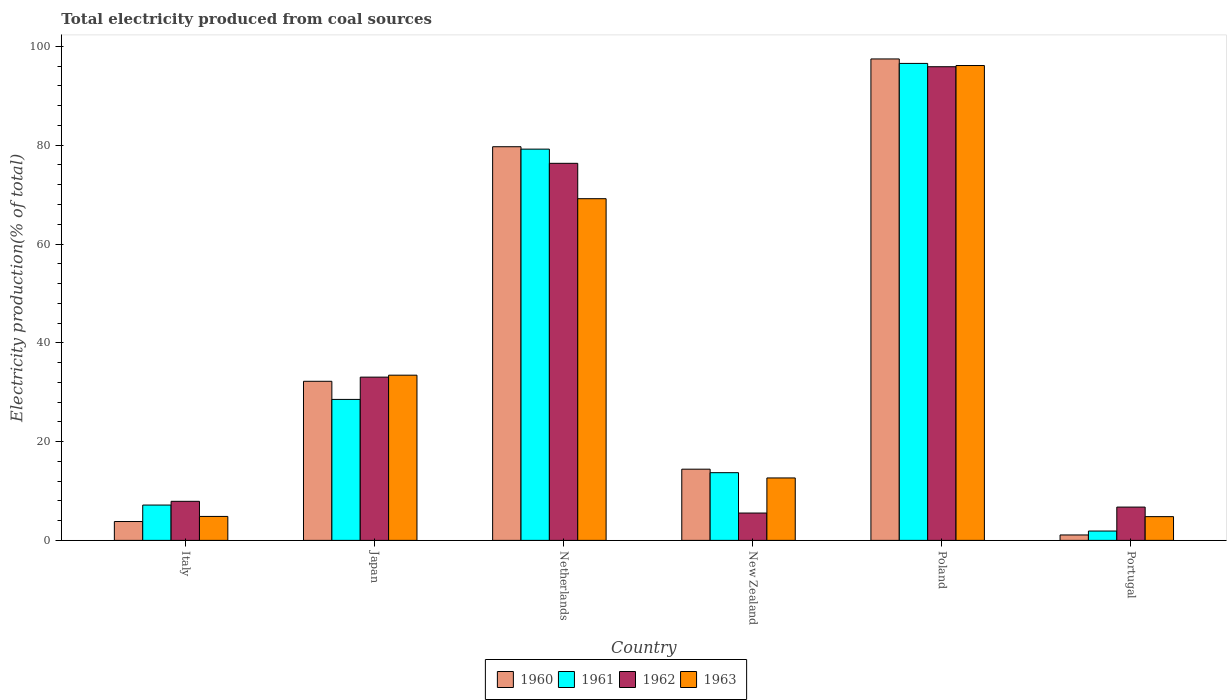How many different coloured bars are there?
Offer a terse response. 4. Are the number of bars per tick equal to the number of legend labels?
Provide a succinct answer. Yes. What is the label of the 5th group of bars from the left?
Make the answer very short. Poland. In how many cases, is the number of bars for a given country not equal to the number of legend labels?
Ensure brevity in your answer.  0. What is the total electricity produced in 1962 in Netherlands?
Offer a terse response. 76.33. Across all countries, what is the maximum total electricity produced in 1961?
Provide a short and direct response. 96.56. Across all countries, what is the minimum total electricity produced in 1963?
Provide a succinct answer. 4.81. In which country was the total electricity produced in 1963 maximum?
Offer a very short reply. Poland. What is the total total electricity produced in 1960 in the graph?
Ensure brevity in your answer.  228.7. What is the difference between the total electricity produced in 1962 in Japan and that in Portugal?
Give a very brief answer. 26.31. What is the difference between the total electricity produced in 1963 in Poland and the total electricity produced in 1961 in Netherlands?
Offer a very short reply. 16.93. What is the average total electricity produced in 1963 per country?
Provide a short and direct response. 36.84. What is the difference between the total electricity produced of/in 1962 and total electricity produced of/in 1963 in Portugal?
Give a very brief answer. 1.93. In how many countries, is the total electricity produced in 1962 greater than 92 %?
Give a very brief answer. 1. What is the ratio of the total electricity produced in 1962 in Japan to that in Netherlands?
Offer a very short reply. 0.43. Is the total electricity produced in 1962 in New Zealand less than that in Portugal?
Provide a succinct answer. Yes. What is the difference between the highest and the second highest total electricity produced in 1963?
Your answer should be very brief. 62.69. What is the difference between the highest and the lowest total electricity produced in 1960?
Offer a very short reply. 96.36. In how many countries, is the total electricity produced in 1960 greater than the average total electricity produced in 1960 taken over all countries?
Offer a very short reply. 2. Is it the case that in every country, the sum of the total electricity produced in 1962 and total electricity produced in 1963 is greater than the sum of total electricity produced in 1961 and total electricity produced in 1960?
Your response must be concise. No. What does the 4th bar from the left in Italy represents?
Your answer should be compact. 1963. Are all the bars in the graph horizontal?
Offer a very short reply. No. How many countries are there in the graph?
Make the answer very short. 6. Where does the legend appear in the graph?
Give a very brief answer. Bottom center. What is the title of the graph?
Your answer should be very brief. Total electricity produced from coal sources. What is the label or title of the X-axis?
Your answer should be compact. Country. What is the Electricity production(% of total) of 1960 in Italy?
Your answer should be very brief. 3.82. What is the Electricity production(% of total) in 1961 in Italy?
Your answer should be very brief. 7.15. What is the Electricity production(% of total) in 1962 in Italy?
Make the answer very short. 7.91. What is the Electricity production(% of total) in 1963 in Italy?
Offer a very short reply. 4.85. What is the Electricity production(% of total) of 1960 in Japan?
Ensure brevity in your answer.  32.21. What is the Electricity production(% of total) of 1961 in Japan?
Provide a short and direct response. 28.54. What is the Electricity production(% of total) in 1962 in Japan?
Your answer should be compact. 33.05. What is the Electricity production(% of total) of 1963 in Japan?
Give a very brief answer. 33.44. What is the Electricity production(% of total) in 1960 in Netherlands?
Offer a terse response. 79.69. What is the Electricity production(% of total) in 1961 in Netherlands?
Provide a succinct answer. 79.2. What is the Electricity production(% of total) of 1962 in Netherlands?
Offer a terse response. 76.33. What is the Electricity production(% of total) in 1963 in Netherlands?
Offer a very short reply. 69.17. What is the Electricity production(% of total) of 1960 in New Zealand?
Make the answer very short. 14.42. What is the Electricity production(% of total) in 1961 in New Zealand?
Provide a short and direct response. 13.71. What is the Electricity production(% of total) of 1962 in New Zealand?
Your answer should be very brief. 5.54. What is the Electricity production(% of total) in 1963 in New Zealand?
Give a very brief answer. 12.64. What is the Electricity production(% of total) of 1960 in Poland?
Provide a short and direct response. 97.46. What is the Electricity production(% of total) in 1961 in Poland?
Make the answer very short. 96.56. What is the Electricity production(% of total) of 1962 in Poland?
Your response must be concise. 95.89. What is the Electricity production(% of total) in 1963 in Poland?
Offer a terse response. 96.13. What is the Electricity production(% of total) in 1960 in Portugal?
Provide a short and direct response. 1.1. What is the Electricity production(% of total) of 1961 in Portugal?
Make the answer very short. 1.89. What is the Electricity production(% of total) of 1962 in Portugal?
Keep it short and to the point. 6.74. What is the Electricity production(% of total) of 1963 in Portugal?
Your answer should be compact. 4.81. Across all countries, what is the maximum Electricity production(% of total) of 1960?
Your answer should be compact. 97.46. Across all countries, what is the maximum Electricity production(% of total) of 1961?
Provide a succinct answer. 96.56. Across all countries, what is the maximum Electricity production(% of total) in 1962?
Offer a terse response. 95.89. Across all countries, what is the maximum Electricity production(% of total) of 1963?
Your response must be concise. 96.13. Across all countries, what is the minimum Electricity production(% of total) of 1960?
Keep it short and to the point. 1.1. Across all countries, what is the minimum Electricity production(% of total) in 1961?
Provide a short and direct response. 1.89. Across all countries, what is the minimum Electricity production(% of total) of 1962?
Provide a short and direct response. 5.54. Across all countries, what is the minimum Electricity production(% of total) in 1963?
Your answer should be very brief. 4.81. What is the total Electricity production(% of total) of 1960 in the graph?
Your answer should be very brief. 228.7. What is the total Electricity production(% of total) of 1961 in the graph?
Your answer should be compact. 227.06. What is the total Electricity production(% of total) of 1962 in the graph?
Offer a very short reply. 225.46. What is the total Electricity production(% of total) in 1963 in the graph?
Offer a terse response. 221.05. What is the difference between the Electricity production(% of total) in 1960 in Italy and that in Japan?
Make the answer very short. -28.39. What is the difference between the Electricity production(% of total) of 1961 in Italy and that in Japan?
Your response must be concise. -21.38. What is the difference between the Electricity production(% of total) in 1962 in Italy and that in Japan?
Provide a succinct answer. -25.14. What is the difference between the Electricity production(% of total) of 1963 in Italy and that in Japan?
Make the answer very short. -28.59. What is the difference between the Electricity production(% of total) in 1960 in Italy and that in Netherlands?
Provide a succinct answer. -75.87. What is the difference between the Electricity production(% of total) of 1961 in Italy and that in Netherlands?
Ensure brevity in your answer.  -72.05. What is the difference between the Electricity production(% of total) in 1962 in Italy and that in Netherlands?
Ensure brevity in your answer.  -68.42. What is the difference between the Electricity production(% of total) in 1963 in Italy and that in Netherlands?
Offer a terse response. -64.32. What is the difference between the Electricity production(% of total) in 1960 in Italy and that in New Zealand?
Your response must be concise. -10.6. What is the difference between the Electricity production(% of total) of 1961 in Italy and that in New Zealand?
Your answer should be very brief. -6.55. What is the difference between the Electricity production(% of total) of 1962 in Italy and that in New Zealand?
Offer a terse response. 2.37. What is the difference between the Electricity production(% of total) in 1963 in Italy and that in New Zealand?
Offer a terse response. -7.79. What is the difference between the Electricity production(% of total) in 1960 in Italy and that in Poland?
Your response must be concise. -93.64. What is the difference between the Electricity production(% of total) in 1961 in Italy and that in Poland?
Give a very brief answer. -89.4. What is the difference between the Electricity production(% of total) of 1962 in Italy and that in Poland?
Offer a terse response. -87.98. What is the difference between the Electricity production(% of total) of 1963 in Italy and that in Poland?
Keep it short and to the point. -91.28. What is the difference between the Electricity production(% of total) of 1960 in Italy and that in Portugal?
Offer a terse response. 2.72. What is the difference between the Electricity production(% of total) in 1961 in Italy and that in Portugal?
Make the answer very short. 5.26. What is the difference between the Electricity production(% of total) of 1962 in Italy and that in Portugal?
Provide a short and direct response. 1.17. What is the difference between the Electricity production(% of total) in 1963 in Italy and that in Portugal?
Keep it short and to the point. 0.04. What is the difference between the Electricity production(% of total) in 1960 in Japan and that in Netherlands?
Your response must be concise. -47.48. What is the difference between the Electricity production(% of total) of 1961 in Japan and that in Netherlands?
Offer a terse response. -50.67. What is the difference between the Electricity production(% of total) in 1962 in Japan and that in Netherlands?
Make the answer very short. -43.28. What is the difference between the Electricity production(% of total) in 1963 in Japan and that in Netherlands?
Give a very brief answer. -35.73. What is the difference between the Electricity production(% of total) of 1960 in Japan and that in New Zealand?
Your answer should be very brief. 17.79. What is the difference between the Electricity production(% of total) of 1961 in Japan and that in New Zealand?
Your response must be concise. 14.83. What is the difference between the Electricity production(% of total) in 1962 in Japan and that in New Zealand?
Your response must be concise. 27.51. What is the difference between the Electricity production(% of total) of 1963 in Japan and that in New Zealand?
Give a very brief answer. 20.8. What is the difference between the Electricity production(% of total) of 1960 in Japan and that in Poland?
Offer a terse response. -65.25. What is the difference between the Electricity production(% of total) in 1961 in Japan and that in Poland?
Give a very brief answer. -68.02. What is the difference between the Electricity production(% of total) of 1962 in Japan and that in Poland?
Keep it short and to the point. -62.84. What is the difference between the Electricity production(% of total) in 1963 in Japan and that in Poland?
Give a very brief answer. -62.69. What is the difference between the Electricity production(% of total) in 1960 in Japan and that in Portugal?
Your response must be concise. 31.11. What is the difference between the Electricity production(% of total) in 1961 in Japan and that in Portugal?
Make the answer very short. 26.64. What is the difference between the Electricity production(% of total) in 1962 in Japan and that in Portugal?
Your response must be concise. 26.31. What is the difference between the Electricity production(% of total) of 1963 in Japan and that in Portugal?
Keep it short and to the point. 28.63. What is the difference between the Electricity production(% of total) of 1960 in Netherlands and that in New Zealand?
Provide a succinct answer. 65.28. What is the difference between the Electricity production(% of total) of 1961 in Netherlands and that in New Zealand?
Make the answer very short. 65.5. What is the difference between the Electricity production(% of total) of 1962 in Netherlands and that in New Zealand?
Offer a terse response. 70.8. What is the difference between the Electricity production(% of total) of 1963 in Netherlands and that in New Zealand?
Make the answer very short. 56.53. What is the difference between the Electricity production(% of total) in 1960 in Netherlands and that in Poland?
Provide a short and direct response. -17.77. What is the difference between the Electricity production(% of total) of 1961 in Netherlands and that in Poland?
Your answer should be very brief. -17.35. What is the difference between the Electricity production(% of total) of 1962 in Netherlands and that in Poland?
Give a very brief answer. -19.56. What is the difference between the Electricity production(% of total) in 1963 in Netherlands and that in Poland?
Keep it short and to the point. -26.96. What is the difference between the Electricity production(% of total) in 1960 in Netherlands and that in Portugal?
Provide a short and direct response. 78.59. What is the difference between the Electricity production(% of total) of 1961 in Netherlands and that in Portugal?
Offer a very short reply. 77.31. What is the difference between the Electricity production(% of total) of 1962 in Netherlands and that in Portugal?
Offer a terse response. 69.59. What is the difference between the Electricity production(% of total) in 1963 in Netherlands and that in Portugal?
Offer a very short reply. 64.36. What is the difference between the Electricity production(% of total) of 1960 in New Zealand and that in Poland?
Offer a very short reply. -83.05. What is the difference between the Electricity production(% of total) of 1961 in New Zealand and that in Poland?
Provide a short and direct response. -82.85. What is the difference between the Electricity production(% of total) of 1962 in New Zealand and that in Poland?
Your answer should be compact. -90.35. What is the difference between the Electricity production(% of total) in 1963 in New Zealand and that in Poland?
Offer a terse response. -83.49. What is the difference between the Electricity production(% of total) in 1960 in New Zealand and that in Portugal?
Your response must be concise. 13.32. What is the difference between the Electricity production(% of total) of 1961 in New Zealand and that in Portugal?
Provide a short and direct response. 11.81. What is the difference between the Electricity production(% of total) of 1962 in New Zealand and that in Portugal?
Provide a succinct answer. -1.2. What is the difference between the Electricity production(% of total) in 1963 in New Zealand and that in Portugal?
Your answer should be compact. 7.83. What is the difference between the Electricity production(% of total) in 1960 in Poland and that in Portugal?
Offer a very short reply. 96.36. What is the difference between the Electricity production(% of total) of 1961 in Poland and that in Portugal?
Provide a succinct answer. 94.66. What is the difference between the Electricity production(% of total) of 1962 in Poland and that in Portugal?
Your answer should be very brief. 89.15. What is the difference between the Electricity production(% of total) in 1963 in Poland and that in Portugal?
Your answer should be very brief. 91.32. What is the difference between the Electricity production(% of total) in 1960 in Italy and the Electricity production(% of total) in 1961 in Japan?
Make the answer very short. -24.72. What is the difference between the Electricity production(% of total) in 1960 in Italy and the Electricity production(% of total) in 1962 in Japan?
Your response must be concise. -29.23. What is the difference between the Electricity production(% of total) of 1960 in Italy and the Electricity production(% of total) of 1963 in Japan?
Offer a very short reply. -29.63. What is the difference between the Electricity production(% of total) of 1961 in Italy and the Electricity production(% of total) of 1962 in Japan?
Make the answer very short. -25.89. What is the difference between the Electricity production(% of total) in 1961 in Italy and the Electricity production(% of total) in 1963 in Japan?
Keep it short and to the point. -26.29. What is the difference between the Electricity production(% of total) of 1962 in Italy and the Electricity production(% of total) of 1963 in Japan?
Your response must be concise. -25.53. What is the difference between the Electricity production(% of total) of 1960 in Italy and the Electricity production(% of total) of 1961 in Netherlands?
Ensure brevity in your answer.  -75.39. What is the difference between the Electricity production(% of total) of 1960 in Italy and the Electricity production(% of total) of 1962 in Netherlands?
Your answer should be very brief. -72.51. What is the difference between the Electricity production(% of total) in 1960 in Italy and the Electricity production(% of total) in 1963 in Netherlands?
Make the answer very short. -65.35. What is the difference between the Electricity production(% of total) in 1961 in Italy and the Electricity production(% of total) in 1962 in Netherlands?
Provide a short and direct response. -69.18. What is the difference between the Electricity production(% of total) in 1961 in Italy and the Electricity production(% of total) in 1963 in Netherlands?
Your answer should be compact. -62.02. What is the difference between the Electricity production(% of total) in 1962 in Italy and the Electricity production(% of total) in 1963 in Netherlands?
Keep it short and to the point. -61.26. What is the difference between the Electricity production(% of total) of 1960 in Italy and the Electricity production(% of total) of 1961 in New Zealand?
Your answer should be compact. -9.89. What is the difference between the Electricity production(% of total) in 1960 in Italy and the Electricity production(% of total) in 1962 in New Zealand?
Your response must be concise. -1.72. What is the difference between the Electricity production(% of total) in 1960 in Italy and the Electricity production(% of total) in 1963 in New Zealand?
Ensure brevity in your answer.  -8.82. What is the difference between the Electricity production(% of total) of 1961 in Italy and the Electricity production(% of total) of 1962 in New Zealand?
Offer a very short reply. 1.62. What is the difference between the Electricity production(% of total) in 1961 in Italy and the Electricity production(% of total) in 1963 in New Zealand?
Your answer should be very brief. -5.49. What is the difference between the Electricity production(% of total) in 1962 in Italy and the Electricity production(% of total) in 1963 in New Zealand?
Offer a terse response. -4.73. What is the difference between the Electricity production(% of total) in 1960 in Italy and the Electricity production(% of total) in 1961 in Poland?
Your answer should be very brief. -92.74. What is the difference between the Electricity production(% of total) in 1960 in Italy and the Electricity production(% of total) in 1962 in Poland?
Offer a terse response. -92.07. What is the difference between the Electricity production(% of total) in 1960 in Italy and the Electricity production(% of total) in 1963 in Poland?
Provide a succinct answer. -92.31. What is the difference between the Electricity production(% of total) in 1961 in Italy and the Electricity production(% of total) in 1962 in Poland?
Ensure brevity in your answer.  -88.73. What is the difference between the Electricity production(% of total) of 1961 in Italy and the Electricity production(% of total) of 1963 in Poland?
Offer a very short reply. -88.98. What is the difference between the Electricity production(% of total) of 1962 in Italy and the Electricity production(% of total) of 1963 in Poland?
Your answer should be very brief. -88.22. What is the difference between the Electricity production(% of total) in 1960 in Italy and the Electricity production(% of total) in 1961 in Portugal?
Make the answer very short. 1.92. What is the difference between the Electricity production(% of total) of 1960 in Italy and the Electricity production(% of total) of 1962 in Portugal?
Your answer should be very brief. -2.92. What is the difference between the Electricity production(% of total) of 1960 in Italy and the Electricity production(% of total) of 1963 in Portugal?
Make the answer very short. -0.99. What is the difference between the Electricity production(% of total) of 1961 in Italy and the Electricity production(% of total) of 1962 in Portugal?
Give a very brief answer. 0.41. What is the difference between the Electricity production(% of total) of 1961 in Italy and the Electricity production(% of total) of 1963 in Portugal?
Provide a succinct answer. 2.35. What is the difference between the Electricity production(% of total) of 1962 in Italy and the Electricity production(% of total) of 1963 in Portugal?
Ensure brevity in your answer.  3.1. What is the difference between the Electricity production(% of total) of 1960 in Japan and the Electricity production(% of total) of 1961 in Netherlands?
Your response must be concise. -47. What is the difference between the Electricity production(% of total) of 1960 in Japan and the Electricity production(% of total) of 1962 in Netherlands?
Provide a short and direct response. -44.13. What is the difference between the Electricity production(% of total) of 1960 in Japan and the Electricity production(% of total) of 1963 in Netherlands?
Ensure brevity in your answer.  -36.96. What is the difference between the Electricity production(% of total) in 1961 in Japan and the Electricity production(% of total) in 1962 in Netherlands?
Your answer should be compact. -47.79. What is the difference between the Electricity production(% of total) in 1961 in Japan and the Electricity production(% of total) in 1963 in Netherlands?
Your answer should be compact. -40.63. What is the difference between the Electricity production(% of total) of 1962 in Japan and the Electricity production(% of total) of 1963 in Netherlands?
Offer a very short reply. -36.12. What is the difference between the Electricity production(% of total) of 1960 in Japan and the Electricity production(% of total) of 1961 in New Zealand?
Your response must be concise. 18.5. What is the difference between the Electricity production(% of total) of 1960 in Japan and the Electricity production(% of total) of 1962 in New Zealand?
Make the answer very short. 26.67. What is the difference between the Electricity production(% of total) of 1960 in Japan and the Electricity production(% of total) of 1963 in New Zealand?
Your answer should be compact. 19.57. What is the difference between the Electricity production(% of total) in 1961 in Japan and the Electricity production(% of total) in 1962 in New Zealand?
Keep it short and to the point. 23. What is the difference between the Electricity production(% of total) of 1961 in Japan and the Electricity production(% of total) of 1963 in New Zealand?
Provide a short and direct response. 15.9. What is the difference between the Electricity production(% of total) in 1962 in Japan and the Electricity production(% of total) in 1963 in New Zealand?
Offer a terse response. 20.41. What is the difference between the Electricity production(% of total) of 1960 in Japan and the Electricity production(% of total) of 1961 in Poland?
Provide a short and direct response. -64.35. What is the difference between the Electricity production(% of total) of 1960 in Japan and the Electricity production(% of total) of 1962 in Poland?
Your response must be concise. -63.68. What is the difference between the Electricity production(% of total) of 1960 in Japan and the Electricity production(% of total) of 1963 in Poland?
Offer a very short reply. -63.92. What is the difference between the Electricity production(% of total) of 1961 in Japan and the Electricity production(% of total) of 1962 in Poland?
Your response must be concise. -67.35. What is the difference between the Electricity production(% of total) of 1961 in Japan and the Electricity production(% of total) of 1963 in Poland?
Your answer should be very brief. -67.59. What is the difference between the Electricity production(% of total) in 1962 in Japan and the Electricity production(% of total) in 1963 in Poland?
Ensure brevity in your answer.  -63.08. What is the difference between the Electricity production(% of total) of 1960 in Japan and the Electricity production(% of total) of 1961 in Portugal?
Your answer should be compact. 30.31. What is the difference between the Electricity production(% of total) in 1960 in Japan and the Electricity production(% of total) in 1962 in Portugal?
Keep it short and to the point. 25.47. What is the difference between the Electricity production(% of total) of 1960 in Japan and the Electricity production(% of total) of 1963 in Portugal?
Ensure brevity in your answer.  27.4. What is the difference between the Electricity production(% of total) of 1961 in Japan and the Electricity production(% of total) of 1962 in Portugal?
Offer a very short reply. 21.8. What is the difference between the Electricity production(% of total) of 1961 in Japan and the Electricity production(% of total) of 1963 in Portugal?
Offer a terse response. 23.73. What is the difference between the Electricity production(% of total) in 1962 in Japan and the Electricity production(% of total) in 1963 in Portugal?
Ensure brevity in your answer.  28.24. What is the difference between the Electricity production(% of total) of 1960 in Netherlands and the Electricity production(% of total) of 1961 in New Zealand?
Your answer should be compact. 65.98. What is the difference between the Electricity production(% of total) of 1960 in Netherlands and the Electricity production(% of total) of 1962 in New Zealand?
Ensure brevity in your answer.  74.16. What is the difference between the Electricity production(% of total) of 1960 in Netherlands and the Electricity production(% of total) of 1963 in New Zealand?
Offer a very short reply. 67.05. What is the difference between the Electricity production(% of total) of 1961 in Netherlands and the Electricity production(% of total) of 1962 in New Zealand?
Keep it short and to the point. 73.67. What is the difference between the Electricity production(% of total) of 1961 in Netherlands and the Electricity production(% of total) of 1963 in New Zealand?
Keep it short and to the point. 66.56. What is the difference between the Electricity production(% of total) of 1962 in Netherlands and the Electricity production(% of total) of 1963 in New Zealand?
Provide a succinct answer. 63.69. What is the difference between the Electricity production(% of total) in 1960 in Netherlands and the Electricity production(% of total) in 1961 in Poland?
Ensure brevity in your answer.  -16.86. What is the difference between the Electricity production(% of total) in 1960 in Netherlands and the Electricity production(% of total) in 1962 in Poland?
Provide a short and direct response. -16.2. What is the difference between the Electricity production(% of total) of 1960 in Netherlands and the Electricity production(% of total) of 1963 in Poland?
Ensure brevity in your answer.  -16.44. What is the difference between the Electricity production(% of total) in 1961 in Netherlands and the Electricity production(% of total) in 1962 in Poland?
Keep it short and to the point. -16.68. What is the difference between the Electricity production(% of total) in 1961 in Netherlands and the Electricity production(% of total) in 1963 in Poland?
Provide a short and direct response. -16.93. What is the difference between the Electricity production(% of total) of 1962 in Netherlands and the Electricity production(% of total) of 1963 in Poland?
Offer a very short reply. -19.8. What is the difference between the Electricity production(% of total) in 1960 in Netherlands and the Electricity production(% of total) in 1961 in Portugal?
Provide a short and direct response. 77.8. What is the difference between the Electricity production(% of total) of 1960 in Netherlands and the Electricity production(% of total) of 1962 in Portugal?
Keep it short and to the point. 72.95. What is the difference between the Electricity production(% of total) of 1960 in Netherlands and the Electricity production(% of total) of 1963 in Portugal?
Keep it short and to the point. 74.88. What is the difference between the Electricity production(% of total) in 1961 in Netherlands and the Electricity production(% of total) in 1962 in Portugal?
Provide a short and direct response. 72.46. What is the difference between the Electricity production(% of total) of 1961 in Netherlands and the Electricity production(% of total) of 1963 in Portugal?
Provide a succinct answer. 74.4. What is the difference between the Electricity production(% of total) of 1962 in Netherlands and the Electricity production(% of total) of 1963 in Portugal?
Offer a terse response. 71.52. What is the difference between the Electricity production(% of total) in 1960 in New Zealand and the Electricity production(% of total) in 1961 in Poland?
Ensure brevity in your answer.  -82.14. What is the difference between the Electricity production(% of total) in 1960 in New Zealand and the Electricity production(% of total) in 1962 in Poland?
Provide a short and direct response. -81.47. What is the difference between the Electricity production(% of total) of 1960 in New Zealand and the Electricity production(% of total) of 1963 in Poland?
Make the answer very short. -81.71. What is the difference between the Electricity production(% of total) in 1961 in New Zealand and the Electricity production(% of total) in 1962 in Poland?
Ensure brevity in your answer.  -82.18. What is the difference between the Electricity production(% of total) of 1961 in New Zealand and the Electricity production(% of total) of 1963 in Poland?
Your answer should be compact. -82.42. What is the difference between the Electricity production(% of total) of 1962 in New Zealand and the Electricity production(% of total) of 1963 in Poland?
Your answer should be very brief. -90.6. What is the difference between the Electricity production(% of total) of 1960 in New Zealand and the Electricity production(% of total) of 1961 in Portugal?
Provide a succinct answer. 12.52. What is the difference between the Electricity production(% of total) of 1960 in New Zealand and the Electricity production(% of total) of 1962 in Portugal?
Your response must be concise. 7.68. What is the difference between the Electricity production(% of total) in 1960 in New Zealand and the Electricity production(% of total) in 1963 in Portugal?
Your answer should be very brief. 9.61. What is the difference between the Electricity production(% of total) in 1961 in New Zealand and the Electricity production(% of total) in 1962 in Portugal?
Give a very brief answer. 6.97. What is the difference between the Electricity production(% of total) of 1961 in New Zealand and the Electricity production(% of total) of 1963 in Portugal?
Keep it short and to the point. 8.9. What is the difference between the Electricity production(% of total) in 1962 in New Zealand and the Electricity production(% of total) in 1963 in Portugal?
Your answer should be compact. 0.73. What is the difference between the Electricity production(% of total) of 1960 in Poland and the Electricity production(% of total) of 1961 in Portugal?
Offer a very short reply. 95.57. What is the difference between the Electricity production(% of total) in 1960 in Poland and the Electricity production(% of total) in 1962 in Portugal?
Provide a succinct answer. 90.72. What is the difference between the Electricity production(% of total) of 1960 in Poland and the Electricity production(% of total) of 1963 in Portugal?
Ensure brevity in your answer.  92.65. What is the difference between the Electricity production(% of total) of 1961 in Poland and the Electricity production(% of total) of 1962 in Portugal?
Keep it short and to the point. 89.82. What is the difference between the Electricity production(% of total) of 1961 in Poland and the Electricity production(% of total) of 1963 in Portugal?
Keep it short and to the point. 91.75. What is the difference between the Electricity production(% of total) of 1962 in Poland and the Electricity production(% of total) of 1963 in Portugal?
Ensure brevity in your answer.  91.08. What is the average Electricity production(% of total) in 1960 per country?
Your answer should be very brief. 38.12. What is the average Electricity production(% of total) of 1961 per country?
Give a very brief answer. 37.84. What is the average Electricity production(% of total) of 1962 per country?
Provide a succinct answer. 37.58. What is the average Electricity production(% of total) of 1963 per country?
Provide a succinct answer. 36.84. What is the difference between the Electricity production(% of total) of 1960 and Electricity production(% of total) of 1961 in Italy?
Your response must be concise. -3.34. What is the difference between the Electricity production(% of total) in 1960 and Electricity production(% of total) in 1962 in Italy?
Your response must be concise. -4.09. What is the difference between the Electricity production(% of total) in 1960 and Electricity production(% of total) in 1963 in Italy?
Provide a short and direct response. -1.03. What is the difference between the Electricity production(% of total) in 1961 and Electricity production(% of total) in 1962 in Italy?
Offer a terse response. -0.75. What is the difference between the Electricity production(% of total) in 1961 and Electricity production(% of total) in 1963 in Italy?
Your response must be concise. 2.3. What is the difference between the Electricity production(% of total) in 1962 and Electricity production(% of total) in 1963 in Italy?
Your answer should be very brief. 3.06. What is the difference between the Electricity production(% of total) in 1960 and Electricity production(% of total) in 1961 in Japan?
Your response must be concise. 3.67. What is the difference between the Electricity production(% of total) in 1960 and Electricity production(% of total) in 1962 in Japan?
Make the answer very short. -0.84. What is the difference between the Electricity production(% of total) in 1960 and Electricity production(% of total) in 1963 in Japan?
Your response must be concise. -1.24. What is the difference between the Electricity production(% of total) of 1961 and Electricity production(% of total) of 1962 in Japan?
Make the answer very short. -4.51. What is the difference between the Electricity production(% of total) in 1961 and Electricity production(% of total) in 1963 in Japan?
Your response must be concise. -4.9. What is the difference between the Electricity production(% of total) of 1962 and Electricity production(% of total) of 1963 in Japan?
Keep it short and to the point. -0.4. What is the difference between the Electricity production(% of total) of 1960 and Electricity production(% of total) of 1961 in Netherlands?
Make the answer very short. 0.49. What is the difference between the Electricity production(% of total) in 1960 and Electricity production(% of total) in 1962 in Netherlands?
Keep it short and to the point. 3.36. What is the difference between the Electricity production(% of total) of 1960 and Electricity production(% of total) of 1963 in Netherlands?
Your answer should be very brief. 10.52. What is the difference between the Electricity production(% of total) of 1961 and Electricity production(% of total) of 1962 in Netherlands?
Your answer should be very brief. 2.87. What is the difference between the Electricity production(% of total) in 1961 and Electricity production(% of total) in 1963 in Netherlands?
Give a very brief answer. 10.03. What is the difference between the Electricity production(% of total) in 1962 and Electricity production(% of total) in 1963 in Netherlands?
Offer a very short reply. 7.16. What is the difference between the Electricity production(% of total) in 1960 and Electricity production(% of total) in 1961 in New Zealand?
Your answer should be very brief. 0.71. What is the difference between the Electricity production(% of total) in 1960 and Electricity production(% of total) in 1962 in New Zealand?
Provide a succinct answer. 8.88. What is the difference between the Electricity production(% of total) of 1960 and Electricity production(% of total) of 1963 in New Zealand?
Give a very brief answer. 1.78. What is the difference between the Electricity production(% of total) in 1961 and Electricity production(% of total) in 1962 in New Zealand?
Your answer should be compact. 8.17. What is the difference between the Electricity production(% of total) of 1961 and Electricity production(% of total) of 1963 in New Zealand?
Your response must be concise. 1.07. What is the difference between the Electricity production(% of total) in 1962 and Electricity production(% of total) in 1963 in New Zealand?
Make the answer very short. -7.1. What is the difference between the Electricity production(% of total) in 1960 and Electricity production(% of total) in 1961 in Poland?
Offer a very short reply. 0.91. What is the difference between the Electricity production(% of total) of 1960 and Electricity production(% of total) of 1962 in Poland?
Offer a terse response. 1.57. What is the difference between the Electricity production(% of total) in 1960 and Electricity production(% of total) in 1963 in Poland?
Make the answer very short. 1.33. What is the difference between the Electricity production(% of total) of 1961 and Electricity production(% of total) of 1962 in Poland?
Keep it short and to the point. 0.67. What is the difference between the Electricity production(% of total) in 1961 and Electricity production(% of total) in 1963 in Poland?
Your response must be concise. 0.43. What is the difference between the Electricity production(% of total) of 1962 and Electricity production(% of total) of 1963 in Poland?
Your answer should be compact. -0.24. What is the difference between the Electricity production(% of total) in 1960 and Electricity production(% of total) in 1961 in Portugal?
Provide a short and direct response. -0.8. What is the difference between the Electricity production(% of total) in 1960 and Electricity production(% of total) in 1962 in Portugal?
Your answer should be very brief. -5.64. What is the difference between the Electricity production(% of total) of 1960 and Electricity production(% of total) of 1963 in Portugal?
Keep it short and to the point. -3.71. What is the difference between the Electricity production(% of total) of 1961 and Electricity production(% of total) of 1962 in Portugal?
Your answer should be very brief. -4.85. What is the difference between the Electricity production(% of total) of 1961 and Electricity production(% of total) of 1963 in Portugal?
Keep it short and to the point. -2.91. What is the difference between the Electricity production(% of total) of 1962 and Electricity production(% of total) of 1963 in Portugal?
Your answer should be compact. 1.93. What is the ratio of the Electricity production(% of total) of 1960 in Italy to that in Japan?
Offer a very short reply. 0.12. What is the ratio of the Electricity production(% of total) of 1961 in Italy to that in Japan?
Ensure brevity in your answer.  0.25. What is the ratio of the Electricity production(% of total) in 1962 in Italy to that in Japan?
Offer a very short reply. 0.24. What is the ratio of the Electricity production(% of total) of 1963 in Italy to that in Japan?
Ensure brevity in your answer.  0.15. What is the ratio of the Electricity production(% of total) in 1960 in Italy to that in Netherlands?
Keep it short and to the point. 0.05. What is the ratio of the Electricity production(% of total) in 1961 in Italy to that in Netherlands?
Your answer should be compact. 0.09. What is the ratio of the Electricity production(% of total) in 1962 in Italy to that in Netherlands?
Your response must be concise. 0.1. What is the ratio of the Electricity production(% of total) of 1963 in Italy to that in Netherlands?
Offer a terse response. 0.07. What is the ratio of the Electricity production(% of total) of 1960 in Italy to that in New Zealand?
Make the answer very short. 0.26. What is the ratio of the Electricity production(% of total) of 1961 in Italy to that in New Zealand?
Give a very brief answer. 0.52. What is the ratio of the Electricity production(% of total) of 1962 in Italy to that in New Zealand?
Your answer should be compact. 1.43. What is the ratio of the Electricity production(% of total) in 1963 in Italy to that in New Zealand?
Provide a succinct answer. 0.38. What is the ratio of the Electricity production(% of total) of 1960 in Italy to that in Poland?
Make the answer very short. 0.04. What is the ratio of the Electricity production(% of total) of 1961 in Italy to that in Poland?
Your response must be concise. 0.07. What is the ratio of the Electricity production(% of total) of 1962 in Italy to that in Poland?
Your answer should be very brief. 0.08. What is the ratio of the Electricity production(% of total) of 1963 in Italy to that in Poland?
Offer a terse response. 0.05. What is the ratio of the Electricity production(% of total) of 1960 in Italy to that in Portugal?
Offer a terse response. 3.48. What is the ratio of the Electricity production(% of total) in 1961 in Italy to that in Portugal?
Provide a short and direct response. 3.78. What is the ratio of the Electricity production(% of total) of 1962 in Italy to that in Portugal?
Keep it short and to the point. 1.17. What is the ratio of the Electricity production(% of total) in 1963 in Italy to that in Portugal?
Provide a succinct answer. 1.01. What is the ratio of the Electricity production(% of total) in 1960 in Japan to that in Netherlands?
Give a very brief answer. 0.4. What is the ratio of the Electricity production(% of total) of 1961 in Japan to that in Netherlands?
Provide a short and direct response. 0.36. What is the ratio of the Electricity production(% of total) of 1962 in Japan to that in Netherlands?
Give a very brief answer. 0.43. What is the ratio of the Electricity production(% of total) in 1963 in Japan to that in Netherlands?
Make the answer very short. 0.48. What is the ratio of the Electricity production(% of total) of 1960 in Japan to that in New Zealand?
Keep it short and to the point. 2.23. What is the ratio of the Electricity production(% of total) of 1961 in Japan to that in New Zealand?
Your answer should be very brief. 2.08. What is the ratio of the Electricity production(% of total) of 1962 in Japan to that in New Zealand?
Offer a very short reply. 5.97. What is the ratio of the Electricity production(% of total) of 1963 in Japan to that in New Zealand?
Give a very brief answer. 2.65. What is the ratio of the Electricity production(% of total) in 1960 in Japan to that in Poland?
Your answer should be compact. 0.33. What is the ratio of the Electricity production(% of total) of 1961 in Japan to that in Poland?
Offer a very short reply. 0.3. What is the ratio of the Electricity production(% of total) in 1962 in Japan to that in Poland?
Your answer should be compact. 0.34. What is the ratio of the Electricity production(% of total) in 1963 in Japan to that in Poland?
Offer a terse response. 0.35. What is the ratio of the Electricity production(% of total) of 1960 in Japan to that in Portugal?
Give a very brief answer. 29.34. What is the ratio of the Electricity production(% of total) in 1961 in Japan to that in Portugal?
Your response must be concise. 15.06. What is the ratio of the Electricity production(% of total) in 1962 in Japan to that in Portugal?
Your answer should be very brief. 4.9. What is the ratio of the Electricity production(% of total) in 1963 in Japan to that in Portugal?
Offer a terse response. 6.95. What is the ratio of the Electricity production(% of total) of 1960 in Netherlands to that in New Zealand?
Your response must be concise. 5.53. What is the ratio of the Electricity production(% of total) in 1961 in Netherlands to that in New Zealand?
Ensure brevity in your answer.  5.78. What is the ratio of the Electricity production(% of total) in 1962 in Netherlands to that in New Zealand?
Provide a succinct answer. 13.79. What is the ratio of the Electricity production(% of total) of 1963 in Netherlands to that in New Zealand?
Offer a very short reply. 5.47. What is the ratio of the Electricity production(% of total) in 1960 in Netherlands to that in Poland?
Ensure brevity in your answer.  0.82. What is the ratio of the Electricity production(% of total) in 1961 in Netherlands to that in Poland?
Keep it short and to the point. 0.82. What is the ratio of the Electricity production(% of total) in 1962 in Netherlands to that in Poland?
Your response must be concise. 0.8. What is the ratio of the Electricity production(% of total) of 1963 in Netherlands to that in Poland?
Offer a very short reply. 0.72. What is the ratio of the Electricity production(% of total) in 1960 in Netherlands to that in Portugal?
Your answer should be very brief. 72.59. What is the ratio of the Electricity production(% of total) in 1961 in Netherlands to that in Portugal?
Keep it short and to the point. 41.81. What is the ratio of the Electricity production(% of total) in 1962 in Netherlands to that in Portugal?
Give a very brief answer. 11.32. What is the ratio of the Electricity production(% of total) of 1963 in Netherlands to that in Portugal?
Give a very brief answer. 14.38. What is the ratio of the Electricity production(% of total) of 1960 in New Zealand to that in Poland?
Keep it short and to the point. 0.15. What is the ratio of the Electricity production(% of total) of 1961 in New Zealand to that in Poland?
Offer a terse response. 0.14. What is the ratio of the Electricity production(% of total) of 1962 in New Zealand to that in Poland?
Offer a terse response. 0.06. What is the ratio of the Electricity production(% of total) of 1963 in New Zealand to that in Poland?
Ensure brevity in your answer.  0.13. What is the ratio of the Electricity production(% of total) of 1960 in New Zealand to that in Portugal?
Provide a short and direct response. 13.13. What is the ratio of the Electricity production(% of total) in 1961 in New Zealand to that in Portugal?
Make the answer very short. 7.24. What is the ratio of the Electricity production(% of total) of 1962 in New Zealand to that in Portugal?
Provide a succinct answer. 0.82. What is the ratio of the Electricity production(% of total) in 1963 in New Zealand to that in Portugal?
Ensure brevity in your answer.  2.63. What is the ratio of the Electricity production(% of total) of 1960 in Poland to that in Portugal?
Give a very brief answer. 88.77. What is the ratio of the Electricity production(% of total) in 1961 in Poland to that in Portugal?
Provide a short and direct response. 50.97. What is the ratio of the Electricity production(% of total) of 1962 in Poland to that in Portugal?
Keep it short and to the point. 14.23. What is the ratio of the Electricity production(% of total) in 1963 in Poland to that in Portugal?
Your answer should be very brief. 19.99. What is the difference between the highest and the second highest Electricity production(% of total) of 1960?
Provide a short and direct response. 17.77. What is the difference between the highest and the second highest Electricity production(% of total) of 1961?
Keep it short and to the point. 17.35. What is the difference between the highest and the second highest Electricity production(% of total) in 1962?
Ensure brevity in your answer.  19.56. What is the difference between the highest and the second highest Electricity production(% of total) in 1963?
Make the answer very short. 26.96. What is the difference between the highest and the lowest Electricity production(% of total) in 1960?
Your response must be concise. 96.36. What is the difference between the highest and the lowest Electricity production(% of total) of 1961?
Ensure brevity in your answer.  94.66. What is the difference between the highest and the lowest Electricity production(% of total) of 1962?
Your answer should be compact. 90.35. What is the difference between the highest and the lowest Electricity production(% of total) of 1963?
Your answer should be very brief. 91.32. 